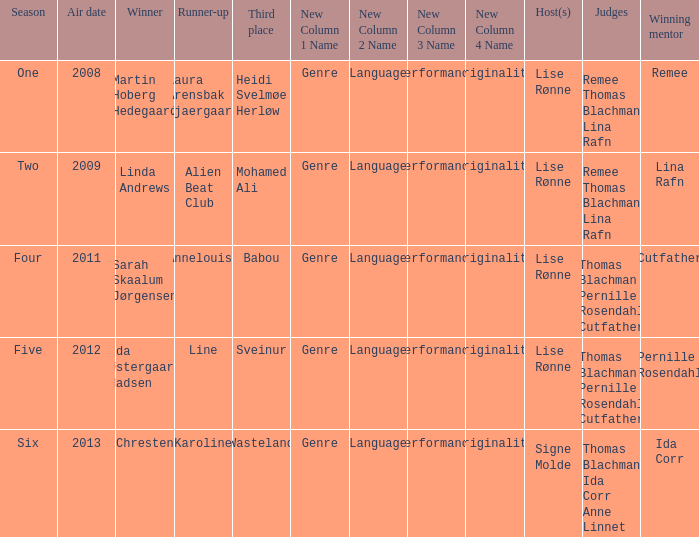Who was the runner-up when Mohamed Ali got third? Alien Beat Club. Write the full table. {'header': ['Season', 'Air date', 'Winner', 'Runner-up', 'Third place', 'New Column 1 Name', 'New Column 2 Name', 'New Column 3 Name', 'New Column 4 Name', 'Host(s)', 'Judges', 'Winning mentor'], 'rows': [['One', '2008', 'Martin Hoberg Hedegaard', 'Laura Arensbak Kjaergaard', 'Heidi Svelmøe Herløw', 'Genre', 'Language', 'Performance', 'Originality', 'Lise Rønne', 'Remee Thomas Blachman Lina Rafn', 'Remee'], ['Two', '2009', 'Linda Andrews', 'Alien Beat Club', 'Mohamed Ali', 'Genre', 'Language', 'Performance', 'Originality', 'Lise Rønne', 'Remee Thomas Blachman Lina Rafn', 'Lina Rafn'], ['Four', '2011', 'Sarah Skaalum Jørgensen', 'Annelouise', 'Babou', 'Genre', 'Language', 'Performance', 'Originality', 'Lise Rønne', 'Thomas Blachman Pernille Rosendahl Cutfather', 'Cutfather'], ['Five', '2012', 'Ida Østergaard Madsen', 'Line', 'Sveinur', 'Genre', 'Language', 'Performance', 'Originality', 'Lise Rønne', 'Thomas Blachman Pernille Rosendahl Cutfather', 'Pernille Rosendahl'], ['Six', '2013', 'Chresten', 'Karoline', 'Wasteland', 'Genre', 'Language', 'Performance', 'Originality', 'Signe Molde', 'Thomas Blachman Ida Corr Anne Linnet', 'Ida Corr']]} 